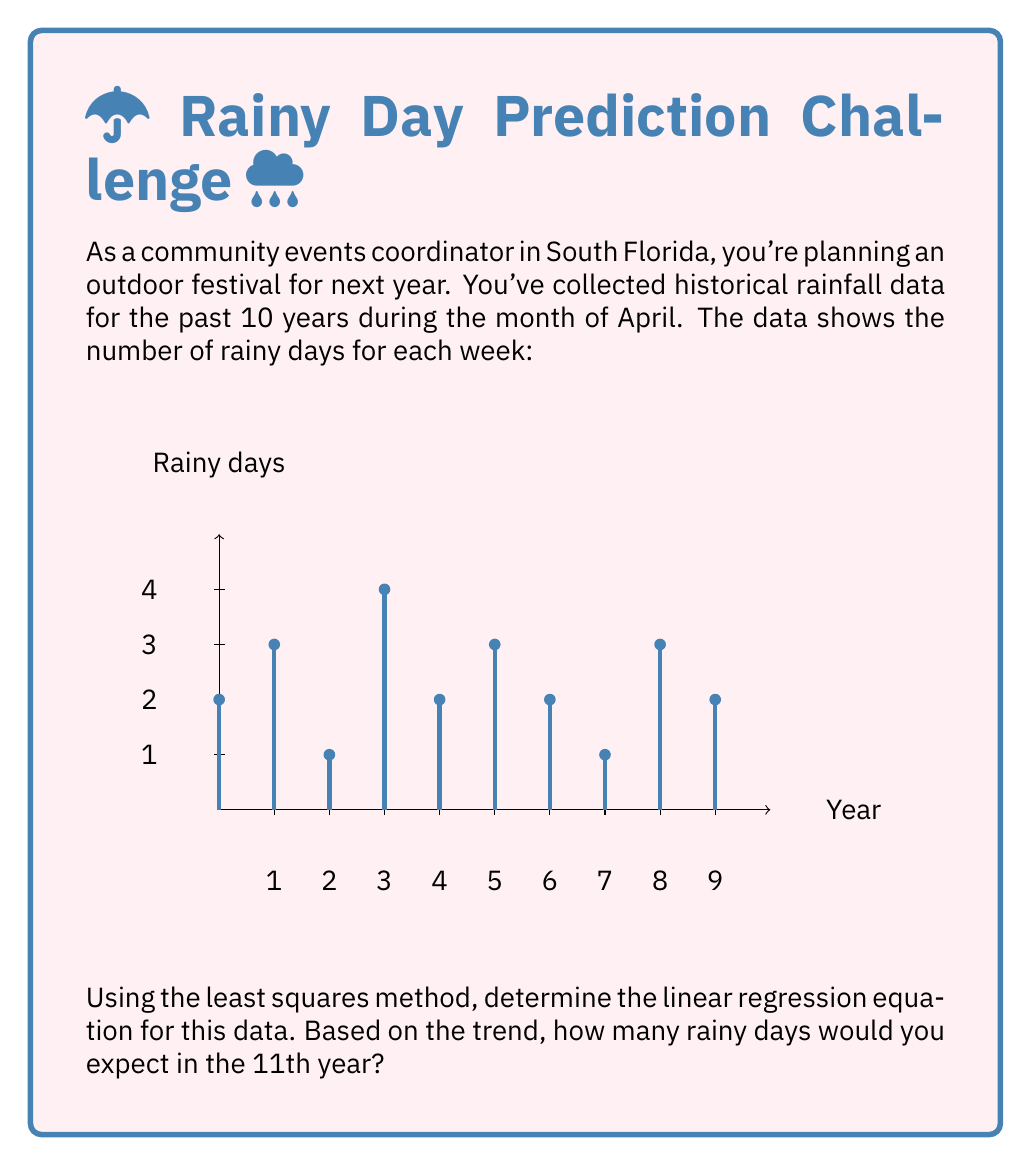Teach me how to tackle this problem. Let's approach this step-by-step:

1) First, we need to calculate the means of x (years) and y (rainy days):
   $\bar{x} = \frac{1+2+3+4+5+6+7+8+9+10}{10} = 5.5$
   $\bar{y} = \frac{2+3+1+4+2+3+2+1+3+2}{10} = 2.3$

2) Now, we calculate the following sums:
   $\sum_{i=1}^{10} (x_i - \bar{x})(y_i - \bar{y})$ and $\sum_{i=1}^{10} (x_i - \bar{x})^2$

3) For the first sum:
   $\sum_{i=1}^{10} (x_i - \bar{x})(y_i - \bar{y}) = (-4.5)(-0.3) + (-3.5)(0.7) + ... + (4.5)(-0.3) = -1.5$

4) For the second sum:
   $\sum_{i=1}^{10} (x_i - \bar{x})^2 = (-4.5)^2 + (-3.5)^2 + ... + (4.5)^2 = 82.5$

5) The slope of the regression line is given by:
   $m = \frac{\sum_{i=1}^{10} (x_i - \bar{x})(y_i - \bar{y})}{\sum_{i=1}^{10} (x_i - \bar{x})^2} = \frac{-1.5}{82.5} = -0.018181818$

6) The y-intercept is calculated using:
   $b = \bar{y} - m\bar{x} = 2.3 - (-0.018181818)(5.5) = 2.4$

7) Therefore, the linear regression equation is:
   $y = -0.018181818x + 2.4$

8) To predict the number of rainy days in the 11th year, we substitute x = 11:
   $y = -0.018181818(11) + 2.4 = 2.2$

9) Rounding to the nearest whole number (as we can't have a fraction of a rainy day), we expect 2 rainy days in the 11th year.
Answer: 2 rainy days 